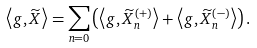<formula> <loc_0><loc_0><loc_500><loc_500>\left \langle g , \widetilde { X } \right \rangle = \sum _ { n = 0 } \left ( \left \langle g , \widetilde { X } _ { n } ^ { \left ( + \right ) } \right \rangle + \left \langle g , \widetilde { X } _ { n } ^ { \left ( - \right ) } \right \rangle \right ) .</formula> 